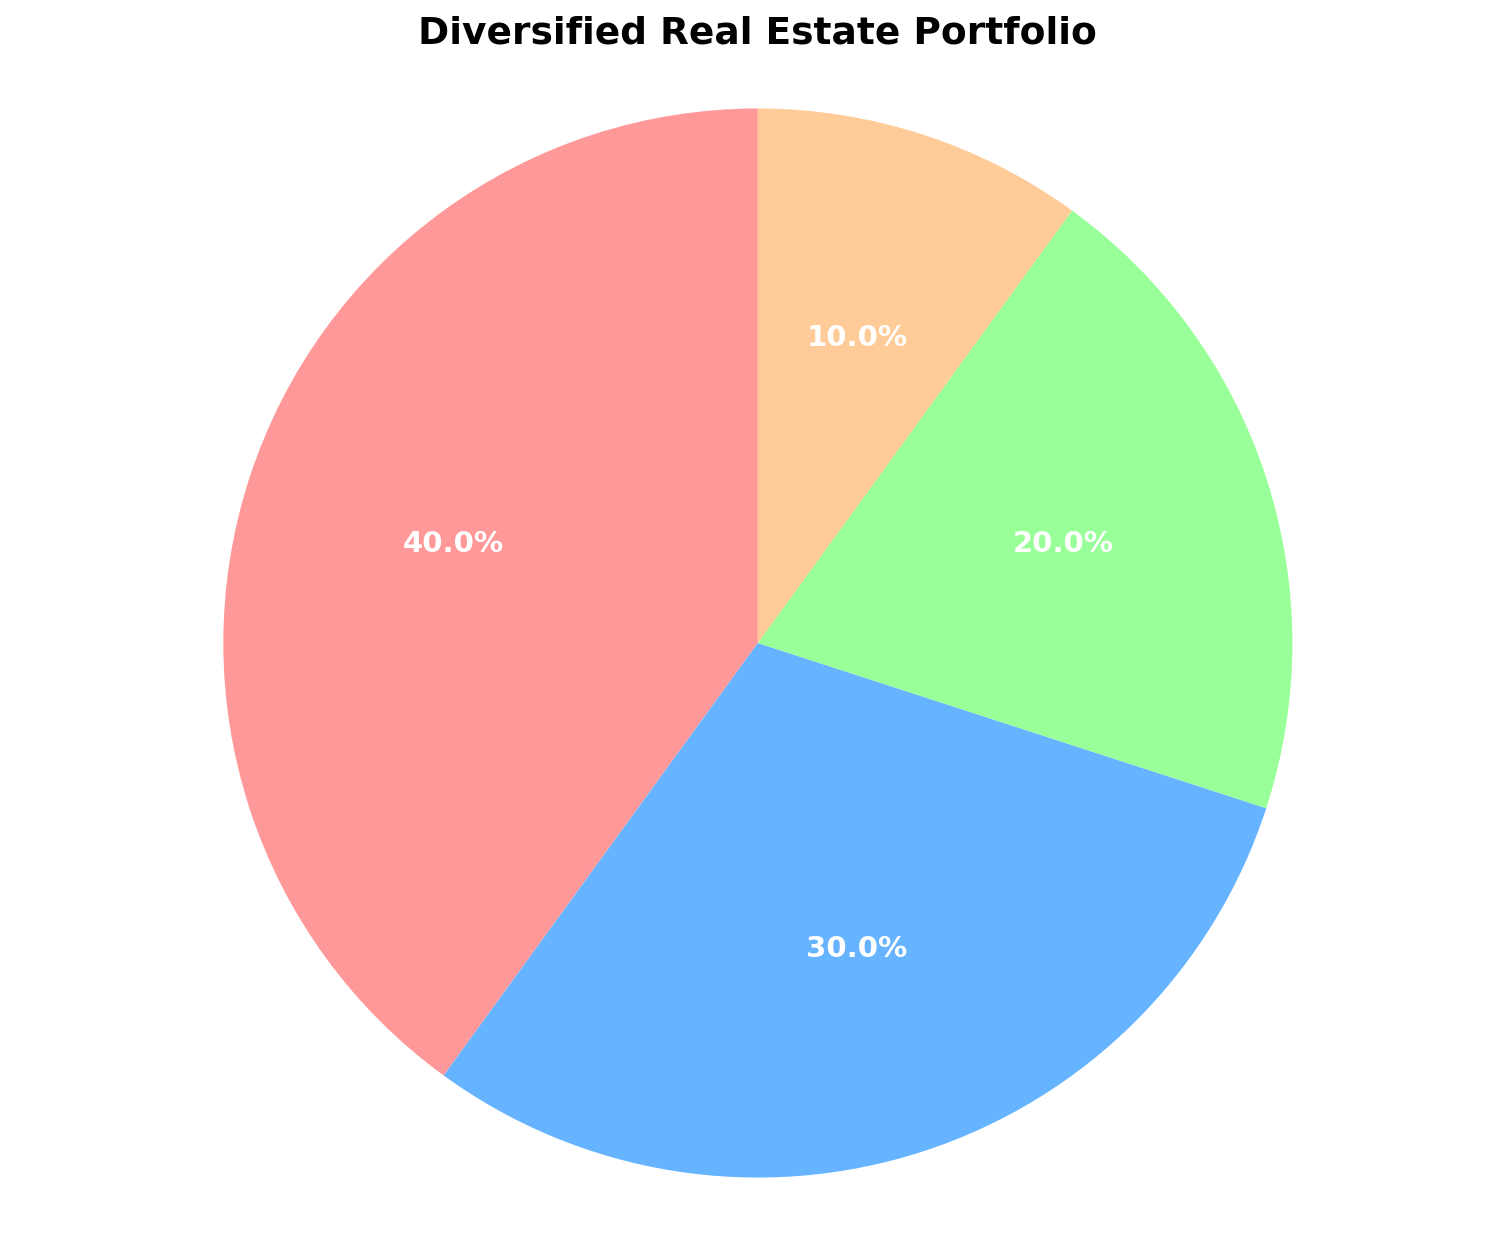Which asset type makes up the largest percentage of the portfolio? The largest percentage is represented by the biggest wedge in the pie chart. It's labeled "Residential" with 40%.
Answer: Residential How much larger is the industrial asset percentage compared to the land asset percentage? The industrial percentage is 20%, and the land percentage is 10%. The difference is 20% - 10% = 10%.
Answer: 10% What is the combined percentage of the residential and commercial assets? The residential percentage is 40%, and the commercial percentage is 30%. The sum is 40% + 30% = 70%.
Answer: 70% Which asset type represents the smallest portion of the portfolio? The smallest portion is represented by the smallest wedge in the pie chart. It's labeled "Land" with 10%.
Answer: Land Is the percentage of commercial assets greater than that of industrial assets? The commercial assets are 30%, and the industrial assets are 20%. Since 30% > 20%, commercial assets have a greater percentage.
Answer: Yes What is the average percentage of the commercial, industrial, and land assets? The commercial is 30%, the industrial is 20%, and the land is 10%. The average is (30% + 20% + 10%)/3 = 60%/3 = 20%.
Answer: 20% How many times larger is the residential asset percentage compared to the land asset percentage? The residential asset percentage is 40%, and the land asset percentage is 10%. The ratio is 40% / 10% = 4 times larger.
Answer: 4 Which two asset types combined make up half of the portfolio? The residential asset is 40%, and the commercial asset is 30%. Their combined percentage is 40% + 30% = 70%, but we need combinations that make 50%. The two that do are industrial (20%) + commercial (30%) or any other combination adding up to 50% from the list given.
Answer: Industrial and Land If the commercial asset's percentage were to drop by 10%, what would the new percentage distribution be for commercial assets? The original commercial asset percentage is 30%. If it drops by 10%, the new percentage is 30% - 10% = 20%.
Answer: 20% 